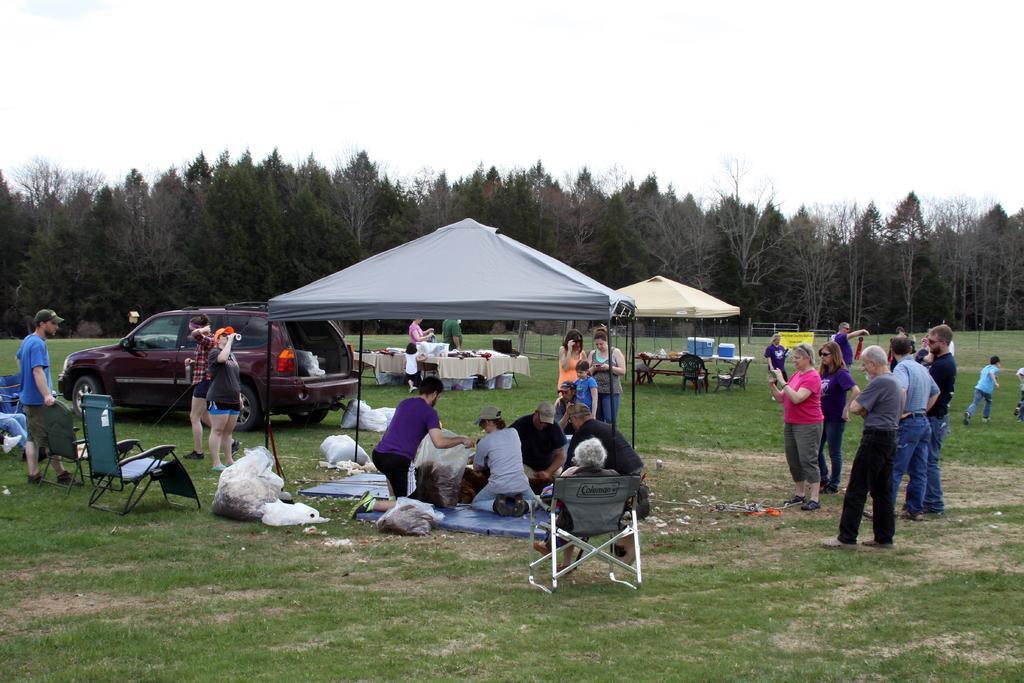Could you give a brief overview of what you see in this image? In the picture we can see the grass surface on it, we can see some people are standing and near to them, we can see some people are sitting under the tent and beside them, we can see a cover bag, chair and we can also see the car parked. In the background, we can see many trees and the sky. 